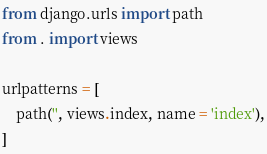Convert code to text. <code><loc_0><loc_0><loc_500><loc_500><_Python_>from django.urls import path
from . import views

urlpatterns = [
    path('', views.index, name = 'index'),
]
</code> 